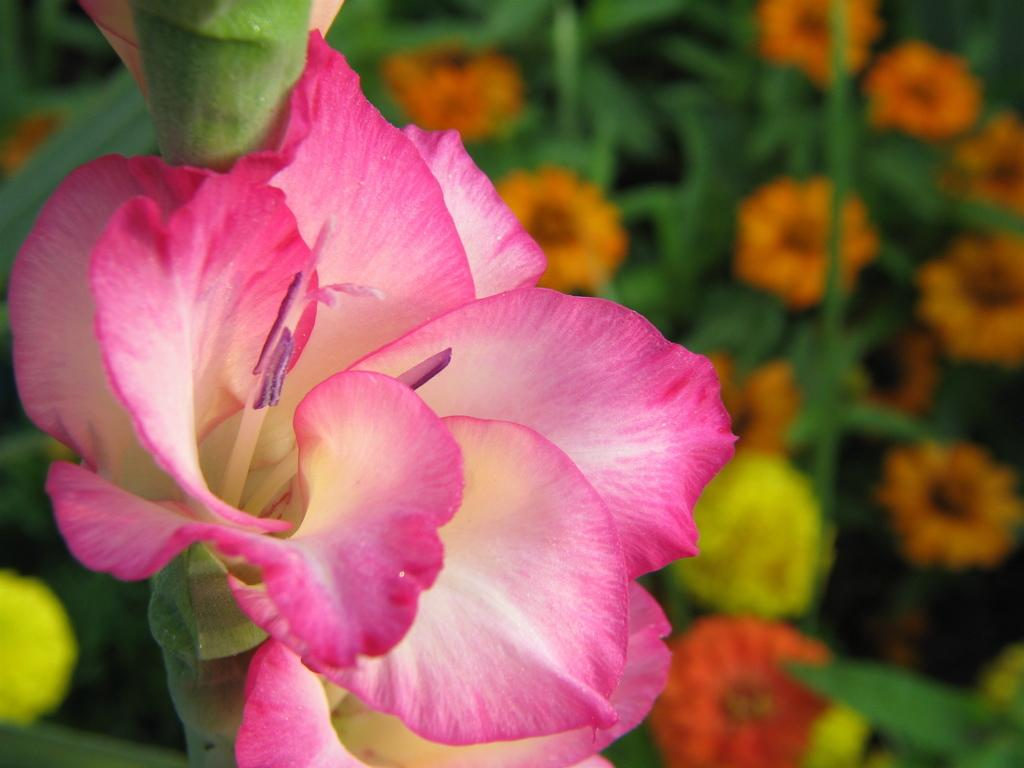What type of plant is in the foreground of the image? There is a flower plant with pink flowers in the foreground of the image. What colors are the flowers in the background of the image? There are flower plants with orange and yellow flowers in the background of the image. How many different types of flower plants can be seen in the image? There are two different types of flower plants in the image, one with pink flowers in the foreground and others with orange and yellow flowers in the background. How many geese are sitting on the hair of the person in the image? There are no geese or people present in the image; it features flower plants with pink, orange, and yellow flowers. 